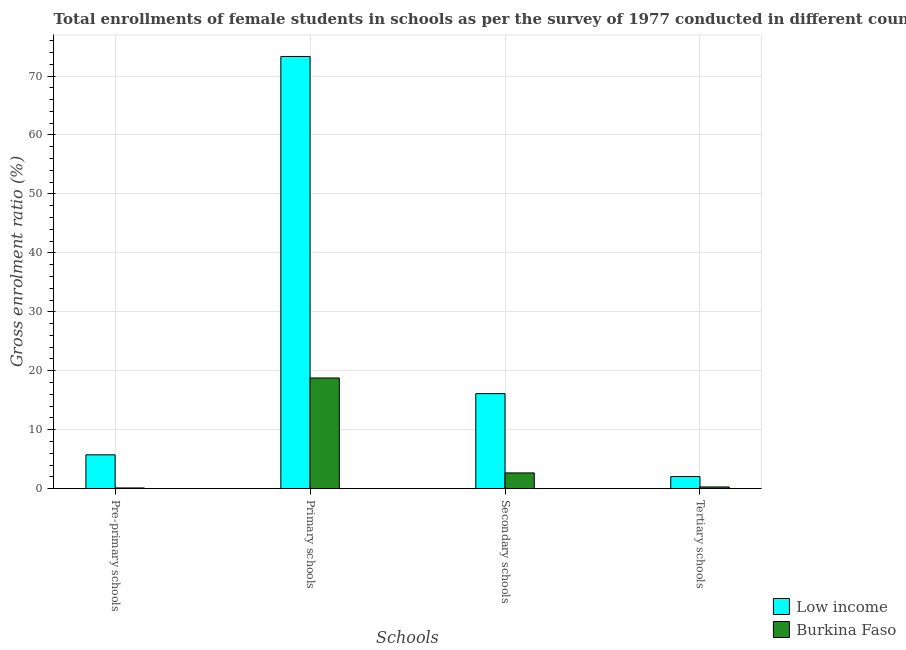Are the number of bars per tick equal to the number of legend labels?
Ensure brevity in your answer.  Yes. How many bars are there on the 3rd tick from the left?
Your answer should be very brief. 2. What is the label of the 4th group of bars from the left?
Offer a terse response. Tertiary schools. What is the gross enrolment ratio(female) in pre-primary schools in Low income?
Provide a succinct answer. 5.74. Across all countries, what is the maximum gross enrolment ratio(female) in pre-primary schools?
Give a very brief answer. 5.74. Across all countries, what is the minimum gross enrolment ratio(female) in tertiary schools?
Offer a very short reply. 0.29. In which country was the gross enrolment ratio(female) in pre-primary schools maximum?
Make the answer very short. Low income. In which country was the gross enrolment ratio(female) in pre-primary schools minimum?
Your answer should be compact. Burkina Faso. What is the total gross enrolment ratio(female) in primary schools in the graph?
Your answer should be compact. 92.09. What is the difference between the gross enrolment ratio(female) in pre-primary schools in Low income and that in Burkina Faso?
Offer a very short reply. 5.62. What is the difference between the gross enrolment ratio(female) in secondary schools in Low income and the gross enrolment ratio(female) in tertiary schools in Burkina Faso?
Your response must be concise. 15.83. What is the average gross enrolment ratio(female) in tertiary schools per country?
Your answer should be very brief. 1.17. What is the difference between the gross enrolment ratio(female) in pre-primary schools and gross enrolment ratio(female) in primary schools in Burkina Faso?
Make the answer very short. -18.65. In how many countries, is the gross enrolment ratio(female) in tertiary schools greater than 34 %?
Your answer should be very brief. 0. What is the ratio of the gross enrolment ratio(female) in tertiary schools in Low income to that in Burkina Faso?
Offer a very short reply. 7.07. What is the difference between the highest and the second highest gross enrolment ratio(female) in pre-primary schools?
Provide a succinct answer. 5.62. What is the difference between the highest and the lowest gross enrolment ratio(female) in pre-primary schools?
Offer a terse response. 5.62. Is the sum of the gross enrolment ratio(female) in primary schools in Burkina Faso and Low income greater than the maximum gross enrolment ratio(female) in secondary schools across all countries?
Your answer should be very brief. Yes. Is it the case that in every country, the sum of the gross enrolment ratio(female) in secondary schools and gross enrolment ratio(female) in tertiary schools is greater than the sum of gross enrolment ratio(female) in pre-primary schools and gross enrolment ratio(female) in primary schools?
Keep it short and to the point. Yes. What does the 2nd bar from the left in Pre-primary schools represents?
Provide a short and direct response. Burkina Faso. Is it the case that in every country, the sum of the gross enrolment ratio(female) in pre-primary schools and gross enrolment ratio(female) in primary schools is greater than the gross enrolment ratio(female) in secondary schools?
Your response must be concise. Yes. Are all the bars in the graph horizontal?
Ensure brevity in your answer.  No. How many countries are there in the graph?
Provide a succinct answer. 2. What is the difference between two consecutive major ticks on the Y-axis?
Your answer should be compact. 10. Does the graph contain grids?
Make the answer very short. Yes. How many legend labels are there?
Give a very brief answer. 2. What is the title of the graph?
Your response must be concise. Total enrollments of female students in schools as per the survey of 1977 conducted in different countries. Does "Paraguay" appear as one of the legend labels in the graph?
Ensure brevity in your answer.  No. What is the label or title of the X-axis?
Provide a succinct answer. Schools. What is the Gross enrolment ratio (%) of Low income in Pre-primary schools?
Make the answer very short. 5.74. What is the Gross enrolment ratio (%) of Burkina Faso in Pre-primary schools?
Give a very brief answer. 0.13. What is the Gross enrolment ratio (%) in Low income in Primary schools?
Offer a terse response. 73.31. What is the Gross enrolment ratio (%) of Burkina Faso in Primary schools?
Your answer should be compact. 18.78. What is the Gross enrolment ratio (%) in Low income in Secondary schools?
Your response must be concise. 16.12. What is the Gross enrolment ratio (%) in Burkina Faso in Secondary schools?
Offer a terse response. 2.67. What is the Gross enrolment ratio (%) in Low income in Tertiary schools?
Offer a very short reply. 2.06. What is the Gross enrolment ratio (%) in Burkina Faso in Tertiary schools?
Give a very brief answer. 0.29. Across all Schools, what is the maximum Gross enrolment ratio (%) of Low income?
Give a very brief answer. 73.31. Across all Schools, what is the maximum Gross enrolment ratio (%) of Burkina Faso?
Offer a terse response. 18.78. Across all Schools, what is the minimum Gross enrolment ratio (%) of Low income?
Make the answer very short. 2.06. Across all Schools, what is the minimum Gross enrolment ratio (%) in Burkina Faso?
Provide a succinct answer. 0.13. What is the total Gross enrolment ratio (%) of Low income in the graph?
Make the answer very short. 97.23. What is the total Gross enrolment ratio (%) of Burkina Faso in the graph?
Ensure brevity in your answer.  21.87. What is the difference between the Gross enrolment ratio (%) of Low income in Pre-primary schools and that in Primary schools?
Give a very brief answer. -67.57. What is the difference between the Gross enrolment ratio (%) in Burkina Faso in Pre-primary schools and that in Primary schools?
Make the answer very short. -18.65. What is the difference between the Gross enrolment ratio (%) in Low income in Pre-primary schools and that in Secondary schools?
Offer a terse response. -10.38. What is the difference between the Gross enrolment ratio (%) in Burkina Faso in Pre-primary schools and that in Secondary schools?
Make the answer very short. -2.55. What is the difference between the Gross enrolment ratio (%) in Low income in Pre-primary schools and that in Tertiary schools?
Provide a succinct answer. 3.69. What is the difference between the Gross enrolment ratio (%) of Burkina Faso in Pre-primary schools and that in Tertiary schools?
Provide a short and direct response. -0.16. What is the difference between the Gross enrolment ratio (%) in Low income in Primary schools and that in Secondary schools?
Your answer should be very brief. 57.19. What is the difference between the Gross enrolment ratio (%) of Burkina Faso in Primary schools and that in Secondary schools?
Give a very brief answer. 16.1. What is the difference between the Gross enrolment ratio (%) in Low income in Primary schools and that in Tertiary schools?
Ensure brevity in your answer.  71.26. What is the difference between the Gross enrolment ratio (%) of Burkina Faso in Primary schools and that in Tertiary schools?
Offer a very short reply. 18.49. What is the difference between the Gross enrolment ratio (%) of Low income in Secondary schools and that in Tertiary schools?
Offer a very short reply. 14.07. What is the difference between the Gross enrolment ratio (%) of Burkina Faso in Secondary schools and that in Tertiary schools?
Give a very brief answer. 2.38. What is the difference between the Gross enrolment ratio (%) of Low income in Pre-primary schools and the Gross enrolment ratio (%) of Burkina Faso in Primary schools?
Ensure brevity in your answer.  -13.03. What is the difference between the Gross enrolment ratio (%) in Low income in Pre-primary schools and the Gross enrolment ratio (%) in Burkina Faso in Secondary schools?
Your answer should be very brief. 3.07. What is the difference between the Gross enrolment ratio (%) of Low income in Pre-primary schools and the Gross enrolment ratio (%) of Burkina Faso in Tertiary schools?
Keep it short and to the point. 5.45. What is the difference between the Gross enrolment ratio (%) of Low income in Primary schools and the Gross enrolment ratio (%) of Burkina Faso in Secondary schools?
Ensure brevity in your answer.  70.64. What is the difference between the Gross enrolment ratio (%) in Low income in Primary schools and the Gross enrolment ratio (%) in Burkina Faso in Tertiary schools?
Provide a succinct answer. 73.02. What is the difference between the Gross enrolment ratio (%) in Low income in Secondary schools and the Gross enrolment ratio (%) in Burkina Faso in Tertiary schools?
Keep it short and to the point. 15.83. What is the average Gross enrolment ratio (%) in Low income per Schools?
Offer a very short reply. 24.31. What is the average Gross enrolment ratio (%) in Burkina Faso per Schools?
Make the answer very short. 5.47. What is the difference between the Gross enrolment ratio (%) in Low income and Gross enrolment ratio (%) in Burkina Faso in Pre-primary schools?
Give a very brief answer. 5.62. What is the difference between the Gross enrolment ratio (%) of Low income and Gross enrolment ratio (%) of Burkina Faso in Primary schools?
Give a very brief answer. 54.53. What is the difference between the Gross enrolment ratio (%) in Low income and Gross enrolment ratio (%) in Burkina Faso in Secondary schools?
Your response must be concise. 13.45. What is the difference between the Gross enrolment ratio (%) in Low income and Gross enrolment ratio (%) in Burkina Faso in Tertiary schools?
Make the answer very short. 1.76. What is the ratio of the Gross enrolment ratio (%) in Low income in Pre-primary schools to that in Primary schools?
Provide a short and direct response. 0.08. What is the ratio of the Gross enrolment ratio (%) of Burkina Faso in Pre-primary schools to that in Primary schools?
Ensure brevity in your answer.  0.01. What is the ratio of the Gross enrolment ratio (%) in Low income in Pre-primary schools to that in Secondary schools?
Give a very brief answer. 0.36. What is the ratio of the Gross enrolment ratio (%) of Burkina Faso in Pre-primary schools to that in Secondary schools?
Provide a succinct answer. 0.05. What is the ratio of the Gross enrolment ratio (%) of Low income in Pre-primary schools to that in Tertiary schools?
Make the answer very short. 2.79. What is the ratio of the Gross enrolment ratio (%) in Burkina Faso in Pre-primary schools to that in Tertiary schools?
Your answer should be compact. 0.43. What is the ratio of the Gross enrolment ratio (%) of Low income in Primary schools to that in Secondary schools?
Offer a very short reply. 4.55. What is the ratio of the Gross enrolment ratio (%) of Burkina Faso in Primary schools to that in Secondary schools?
Provide a short and direct response. 7.03. What is the ratio of the Gross enrolment ratio (%) in Low income in Primary schools to that in Tertiary schools?
Your answer should be compact. 35.67. What is the ratio of the Gross enrolment ratio (%) of Burkina Faso in Primary schools to that in Tertiary schools?
Your response must be concise. 64.55. What is the ratio of the Gross enrolment ratio (%) in Low income in Secondary schools to that in Tertiary schools?
Your response must be concise. 7.84. What is the ratio of the Gross enrolment ratio (%) of Burkina Faso in Secondary schools to that in Tertiary schools?
Ensure brevity in your answer.  9.19. What is the difference between the highest and the second highest Gross enrolment ratio (%) of Low income?
Give a very brief answer. 57.19. What is the difference between the highest and the second highest Gross enrolment ratio (%) in Burkina Faso?
Your response must be concise. 16.1. What is the difference between the highest and the lowest Gross enrolment ratio (%) of Low income?
Provide a succinct answer. 71.26. What is the difference between the highest and the lowest Gross enrolment ratio (%) of Burkina Faso?
Keep it short and to the point. 18.65. 